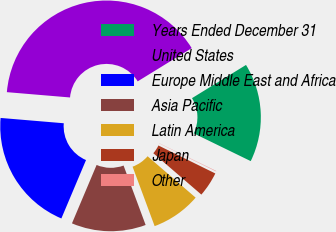Convert chart. <chart><loc_0><loc_0><loc_500><loc_500><pie_chart><fcel>Years Ended December 31<fcel>United States<fcel>Europe Middle East and Africa<fcel>Asia Pacific<fcel>Latin America<fcel>Japan<fcel>Other<nl><fcel>15.99%<fcel>39.89%<fcel>19.98%<fcel>12.01%<fcel>8.03%<fcel>4.04%<fcel>0.06%<nl></chart> 